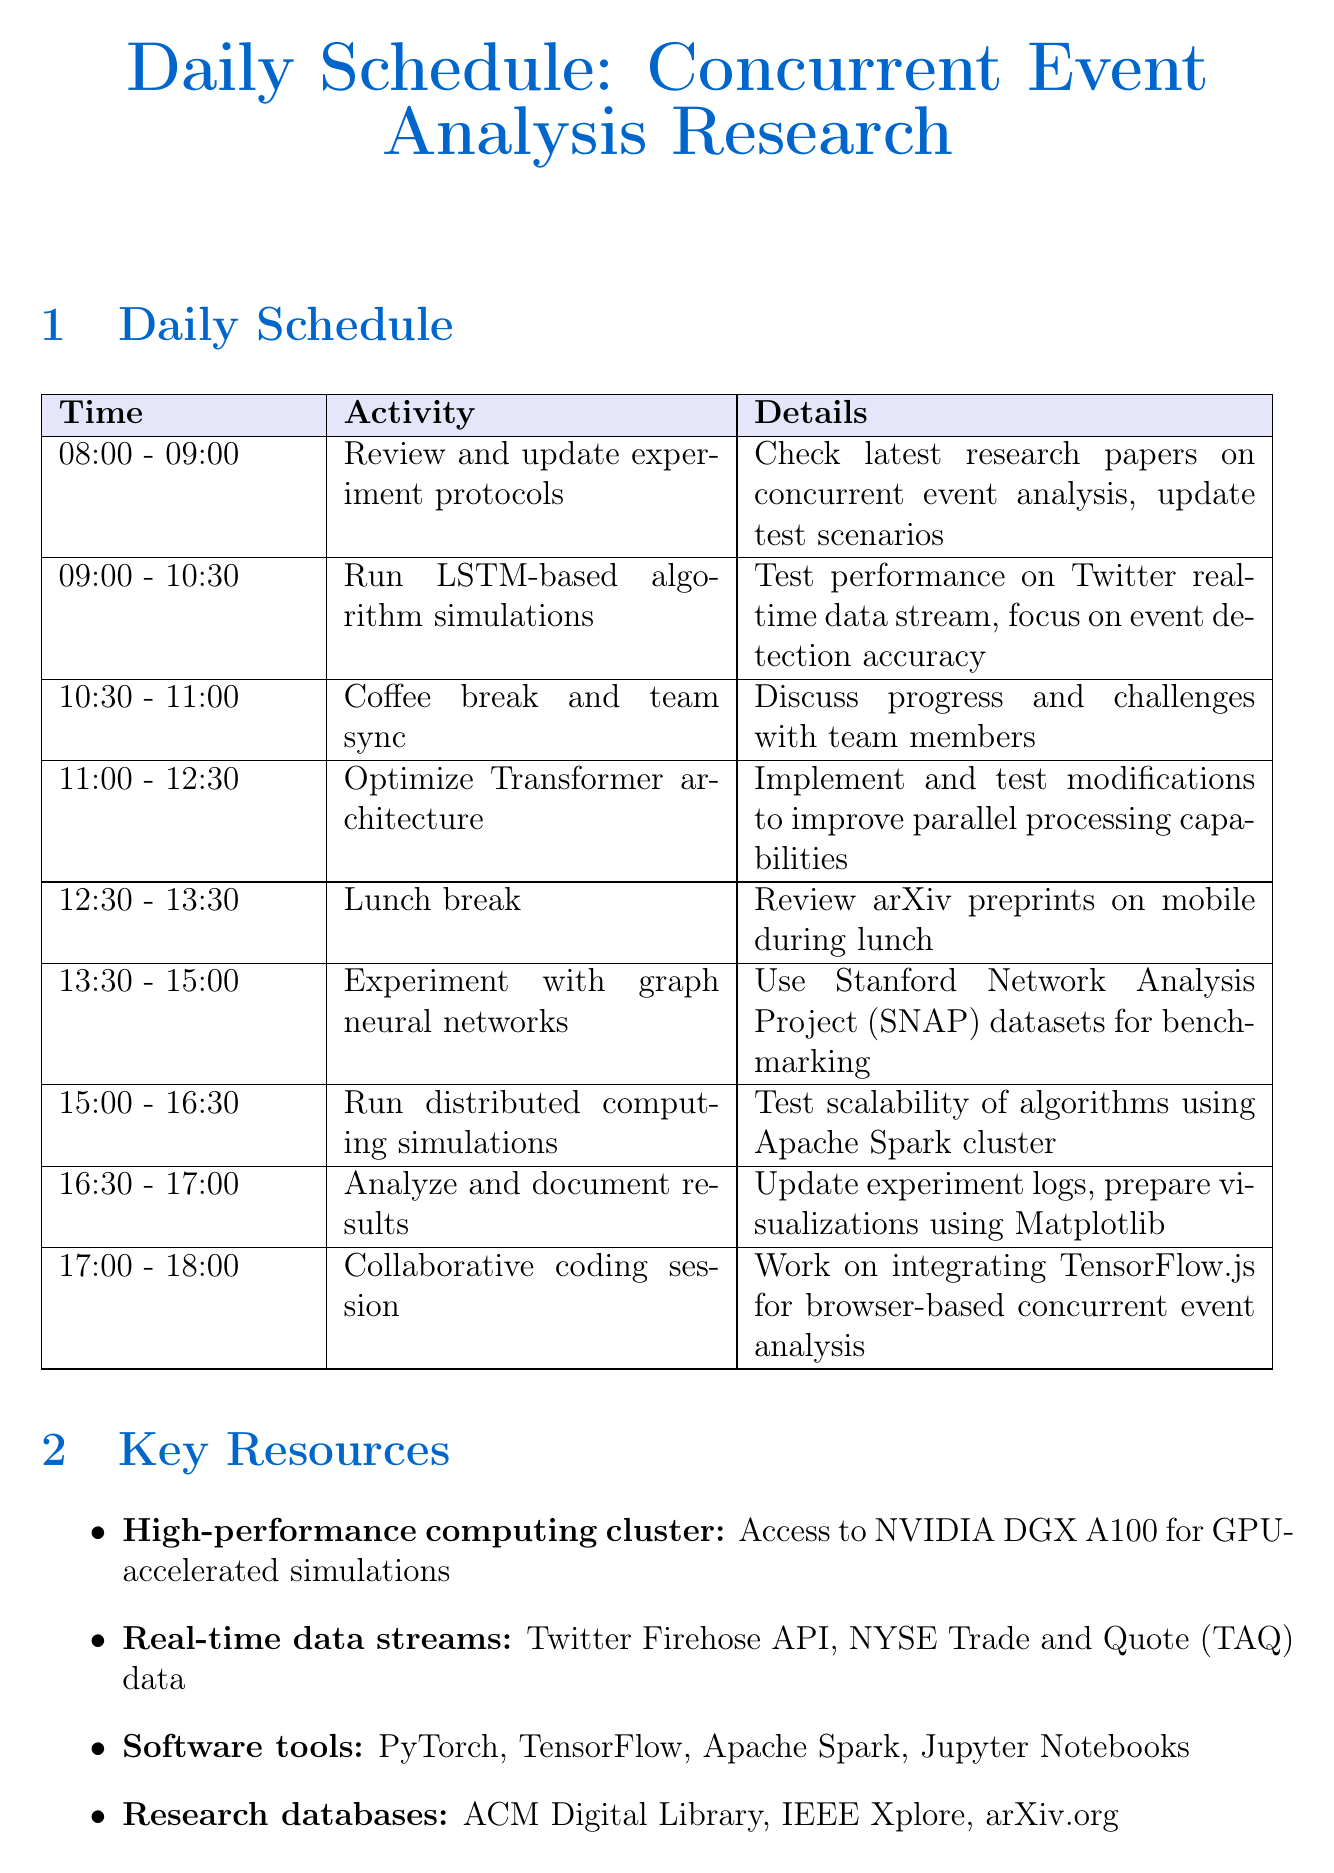What time is lunch break scheduled? The lunch break is scheduled from 12:30 to 13:30.
Answer: 12:30 - 13:30 What is the main focus of the LSTM-based simulations? The main focus is on event detection accuracy using Twitter real-time data stream.
Answer: Event detection accuracy Which software tools are mentioned in the key resources? The software tools listed include PyTorch, TensorFlow, Apache Spark, and Jupyter Notebooks.
Answer: PyTorch, TensorFlow, Apache Spark, Jupyter Notebooks What is the upcoming deadline for ICML 2024 paper submission? The deadline for ICML 2024 paper submission is January 26, 2024.
Answer: January 26, 2024 Who is the collaboration partner for the project on multi-modal event analysis? The collaboration partner is Stanford AI Lab.
Answer: Stanford AI Lab What activity is scheduled immediately after the coffee break? The activity scheduled immediately after the coffee break is optimizing Transformer architecture for concurrent analysis.
Answer: Optimize Transformer architecture During which time slot is the collaborative coding session planned? The collaborative coding session is planned from 17:00 to 18:00.
Answer: 17:00 - 18:00 